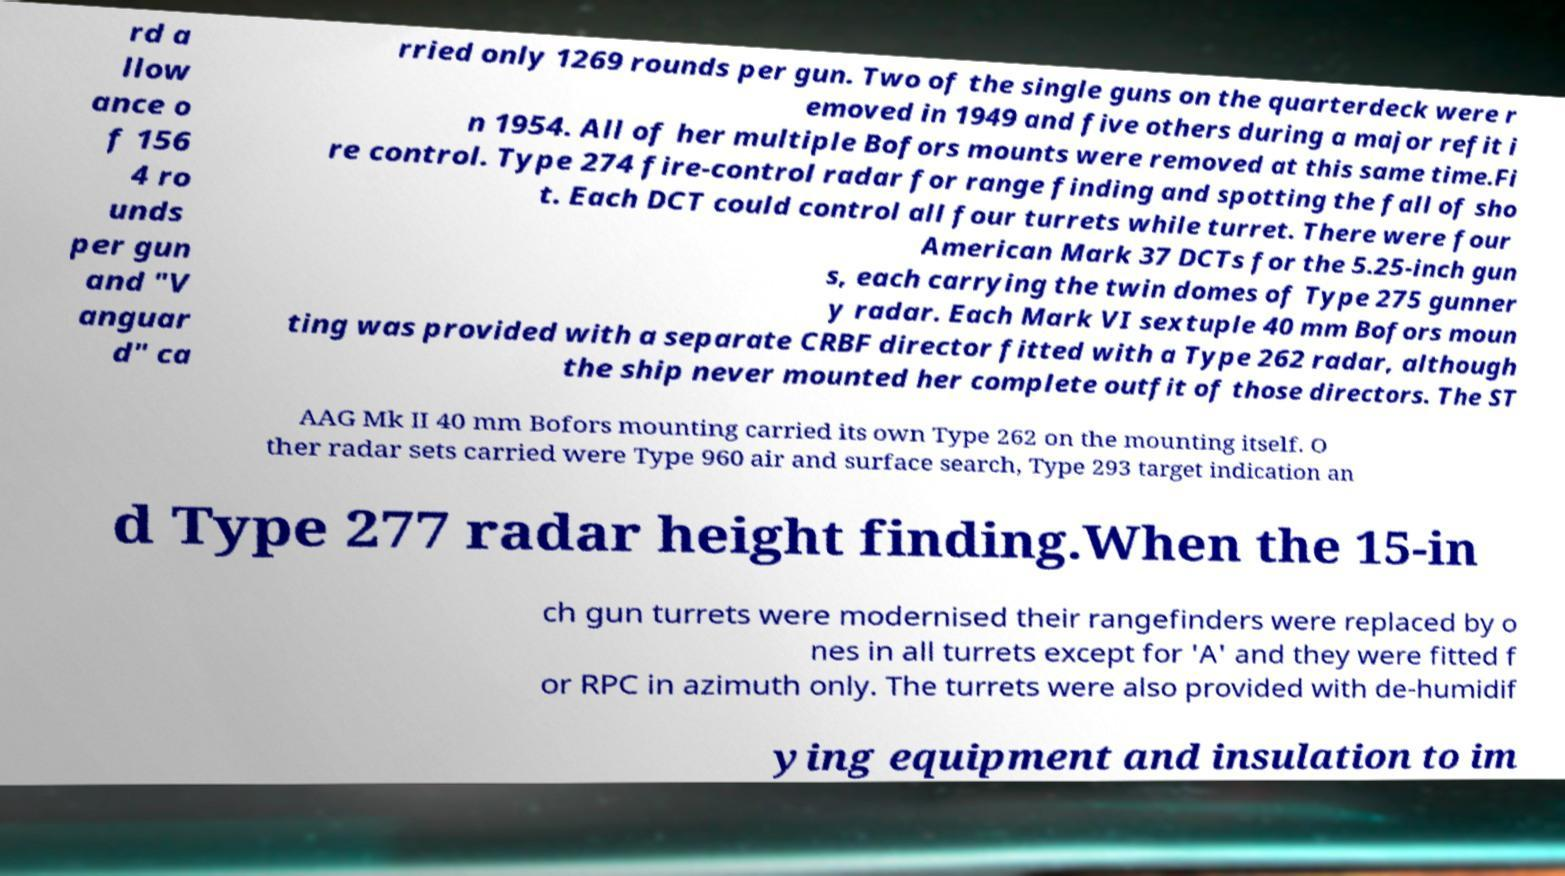What messages or text are displayed in this image? I need them in a readable, typed format. rd a llow ance o f 156 4 ro unds per gun and "V anguar d" ca rried only 1269 rounds per gun. Two of the single guns on the quarterdeck were r emoved in 1949 and five others during a major refit i n 1954. All of her multiple Bofors mounts were removed at this same time.Fi re control. Type 274 fire-control radar for range finding and spotting the fall of sho t. Each DCT could control all four turrets while turret. There were four American Mark 37 DCTs for the 5.25-inch gun s, each carrying the twin domes of Type 275 gunner y radar. Each Mark VI sextuple 40 mm Bofors moun ting was provided with a separate CRBF director fitted with a Type 262 radar, although the ship never mounted her complete outfit of those directors. The ST AAG Mk II 40 mm Bofors mounting carried its own Type 262 on the mounting itself. O ther radar sets carried were Type 960 air and surface search, Type 293 target indication an d Type 277 radar height finding.When the 15-in ch gun turrets were modernised their rangefinders were replaced by o nes in all turrets except for 'A' and they were fitted f or RPC in azimuth only. The turrets were also provided with de-humidif ying equipment and insulation to im 